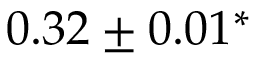<formula> <loc_0><loc_0><loc_500><loc_500>0 . 3 2 \pm 0 . 0 1 ^ { \ast }</formula> 